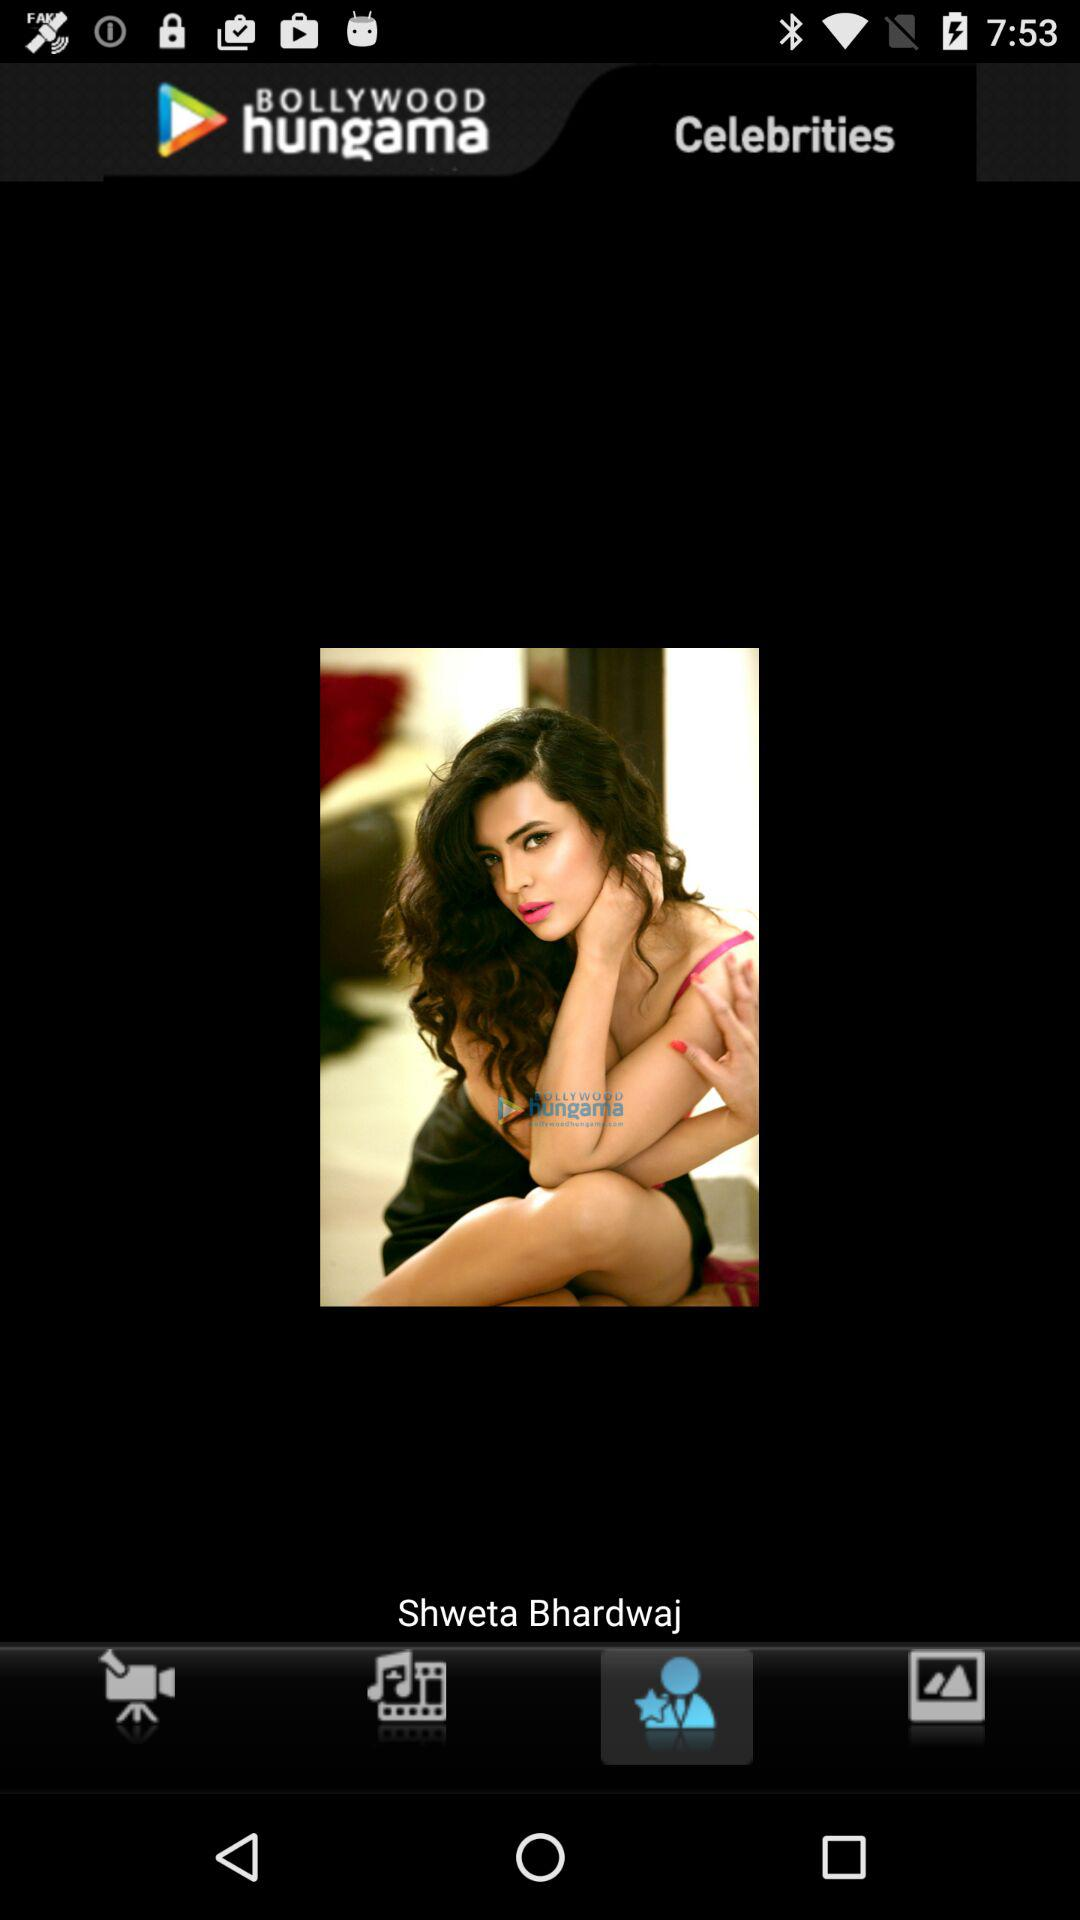What is the name of the application? The name of the application is "BOLLYWOOD hungama". 